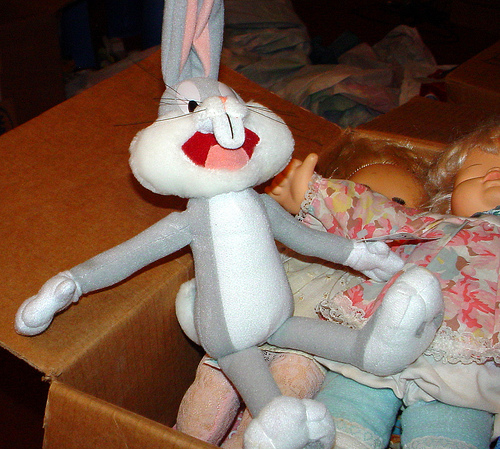<image>
Is there a bunny on the doll? Yes. Looking at the image, I can see the bunny is positioned on top of the doll, with the doll providing support. Where is the rabbit in relation to the doll? Is it above the doll? No. The rabbit is not positioned above the doll. The vertical arrangement shows a different relationship. 